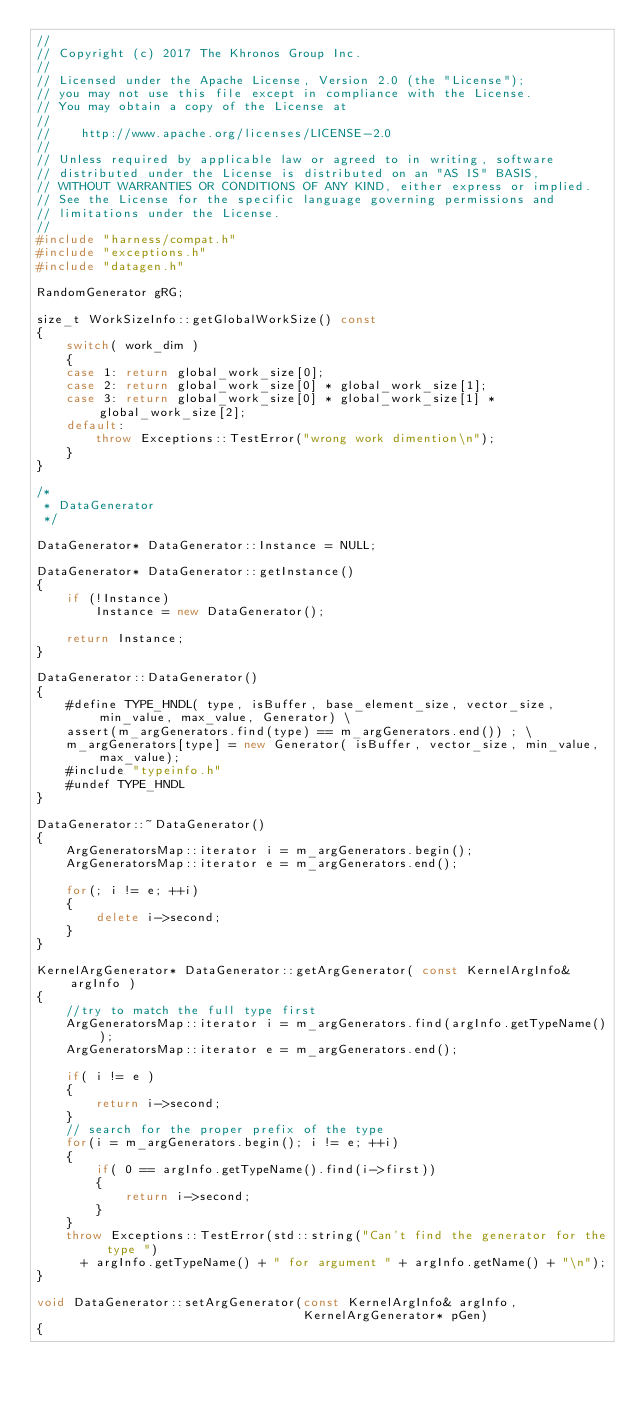Convert code to text. <code><loc_0><loc_0><loc_500><loc_500><_C++_>//
// Copyright (c) 2017 The Khronos Group Inc.
// 
// Licensed under the Apache License, Version 2.0 (the "License");
// you may not use this file except in compliance with the License.
// You may obtain a copy of the License at
//
//    http://www.apache.org/licenses/LICENSE-2.0
//
// Unless required by applicable law or agreed to in writing, software
// distributed under the License is distributed on an "AS IS" BASIS,
// WITHOUT WARRANTIES OR CONDITIONS OF ANY KIND, either express or implied.
// See the License for the specific language governing permissions and
// limitations under the License.
//
#include "harness/compat.h"
#include "exceptions.h"
#include "datagen.h"

RandomGenerator gRG;

size_t WorkSizeInfo::getGlobalWorkSize() const
{
    switch( work_dim )
    {
    case 1: return global_work_size[0];
    case 2: return global_work_size[0] * global_work_size[1];
    case 3: return global_work_size[0] * global_work_size[1] * global_work_size[2];
    default:
        throw Exceptions::TestError("wrong work dimention\n");
    }
}

/*
 * DataGenerator
 */

DataGenerator* DataGenerator::Instance = NULL;

DataGenerator* DataGenerator::getInstance()
{
    if (!Instance)
        Instance = new DataGenerator();

    return Instance;
}

DataGenerator::DataGenerator()
{
    #define TYPE_HNDL( type, isBuffer, base_element_size, vector_size, min_value, max_value, Generator) \
    assert(m_argGenerators.find(type) == m_argGenerators.end()) ; \
    m_argGenerators[type] = new Generator( isBuffer, vector_size, min_value, max_value);
    #include "typeinfo.h"
    #undef TYPE_HNDL
}

DataGenerator::~DataGenerator()
{
    ArgGeneratorsMap::iterator i = m_argGenerators.begin();
    ArgGeneratorsMap::iterator e = m_argGenerators.end();

    for(; i != e; ++i)
    {
        delete i->second;
    }
}

KernelArgGenerator* DataGenerator::getArgGenerator( const KernelArgInfo& argInfo )
{
    //try to match the full type first
    ArgGeneratorsMap::iterator i = m_argGenerators.find(argInfo.getTypeName());
    ArgGeneratorsMap::iterator e = m_argGenerators.end();

    if( i != e )
    {
        return i->second;
    }
    // search for the proper prefix of the type
    for(i = m_argGenerators.begin(); i != e; ++i)
    {
        if( 0 == argInfo.getTypeName().find(i->first))
        {
            return i->second;
        }
    }
    throw Exceptions::TestError(std::string("Can't find the generator for the type ")
      + argInfo.getTypeName() + " for argument " + argInfo.getName() + "\n");
}

void DataGenerator::setArgGenerator(const KernelArgInfo& argInfo,
                                    KernelArgGenerator* pGen)
{</code> 